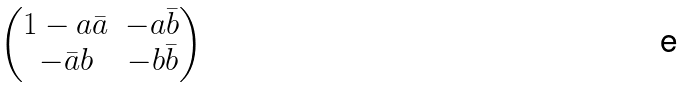Convert formula to latex. <formula><loc_0><loc_0><loc_500><loc_500>\begin{pmatrix} 1 - a { \bar { a } } & - a { \bar { b } } \\ - { \bar { a } } b & - b { \bar { b } } \end{pmatrix}</formula> 